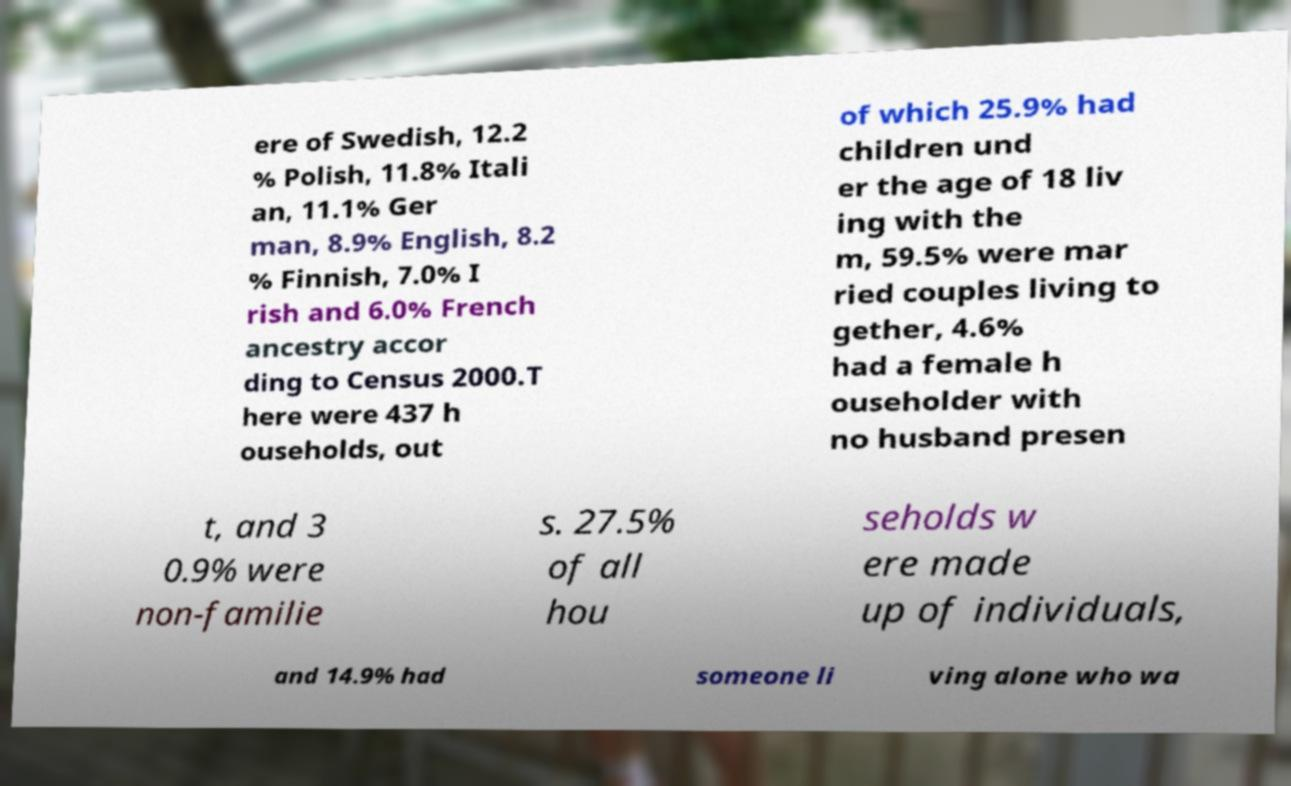What messages or text are displayed in this image? I need them in a readable, typed format. ere of Swedish, 12.2 % Polish, 11.8% Itali an, 11.1% Ger man, 8.9% English, 8.2 % Finnish, 7.0% I rish and 6.0% French ancestry accor ding to Census 2000.T here were 437 h ouseholds, out of which 25.9% had children und er the age of 18 liv ing with the m, 59.5% were mar ried couples living to gether, 4.6% had a female h ouseholder with no husband presen t, and 3 0.9% were non-familie s. 27.5% of all hou seholds w ere made up of individuals, and 14.9% had someone li ving alone who wa 